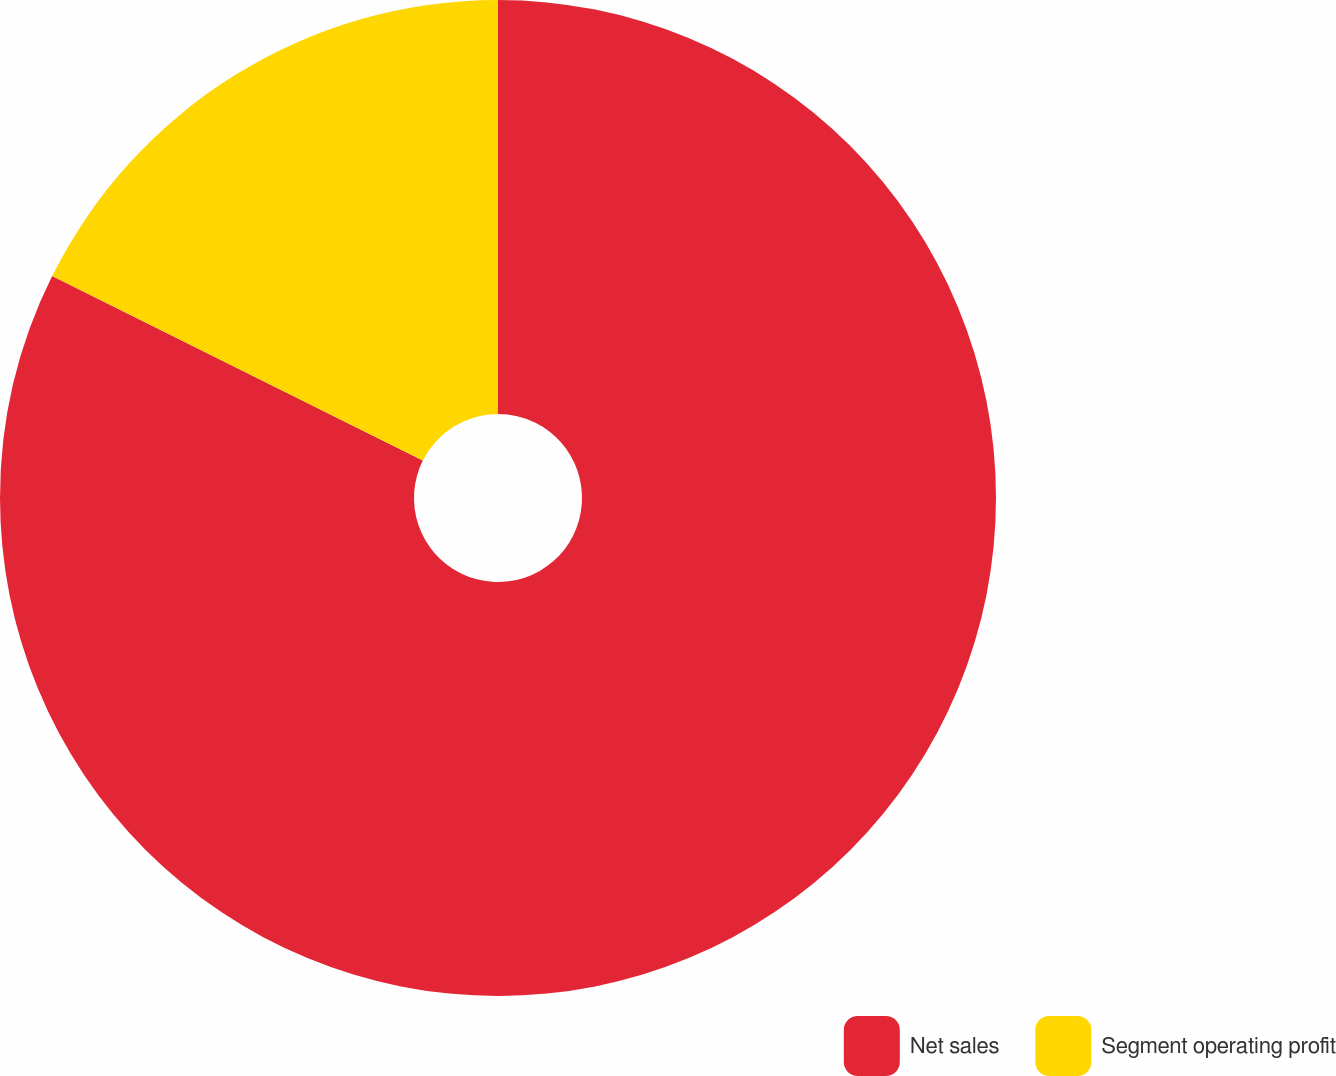<chart> <loc_0><loc_0><loc_500><loc_500><pie_chart><fcel>Net sales<fcel>Segment operating profit<nl><fcel>82.35%<fcel>17.65%<nl></chart> 